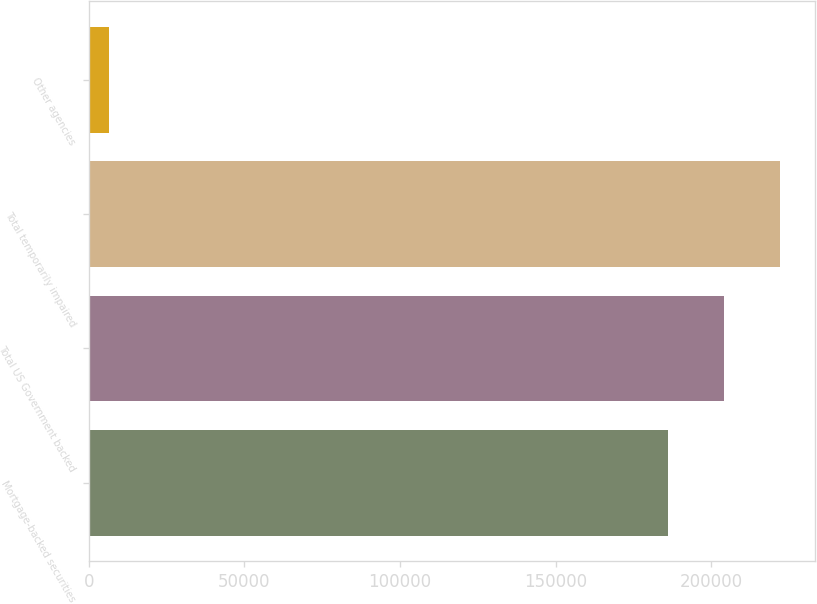<chart> <loc_0><loc_0><loc_500><loc_500><bar_chart><fcel>Mortgage-backed securities<fcel>Total US Government backed<fcel>Total temporarily impaired<fcel>Other agencies<nl><fcel>186226<fcel>204184<fcel>222142<fcel>6647<nl></chart> 